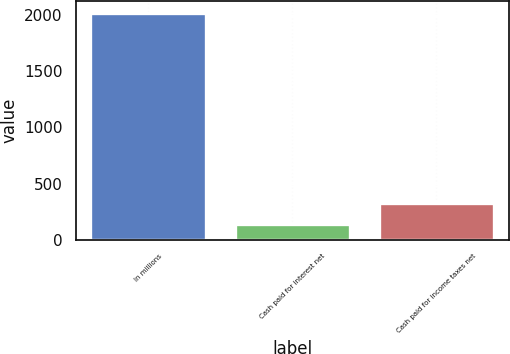Convert chart to OTSL. <chart><loc_0><loc_0><loc_500><loc_500><bar_chart><fcel>In millions<fcel>Cash paid for interest net<fcel>Cash paid for income taxes net<nl><fcel>2016<fcel>143.4<fcel>330.66<nl></chart> 